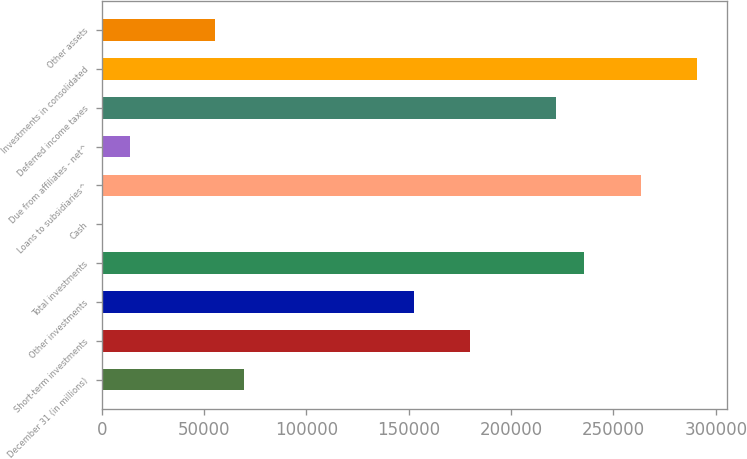Convert chart to OTSL. <chart><loc_0><loc_0><loc_500><loc_500><bar_chart><fcel>December 31 (in millions)<fcel>Short-term investments<fcel>Other investments<fcel>Total investments<fcel>Cash<fcel>Loans to subsidiaries^<fcel>Due from affiliates - net^<fcel>Deferred income taxes<fcel>Investments in consolidated<fcel>Other assets<nl><fcel>69306.5<fcel>180149<fcel>152438<fcel>235570<fcel>30<fcel>263281<fcel>13885.3<fcel>221715<fcel>290991<fcel>55451.2<nl></chart> 